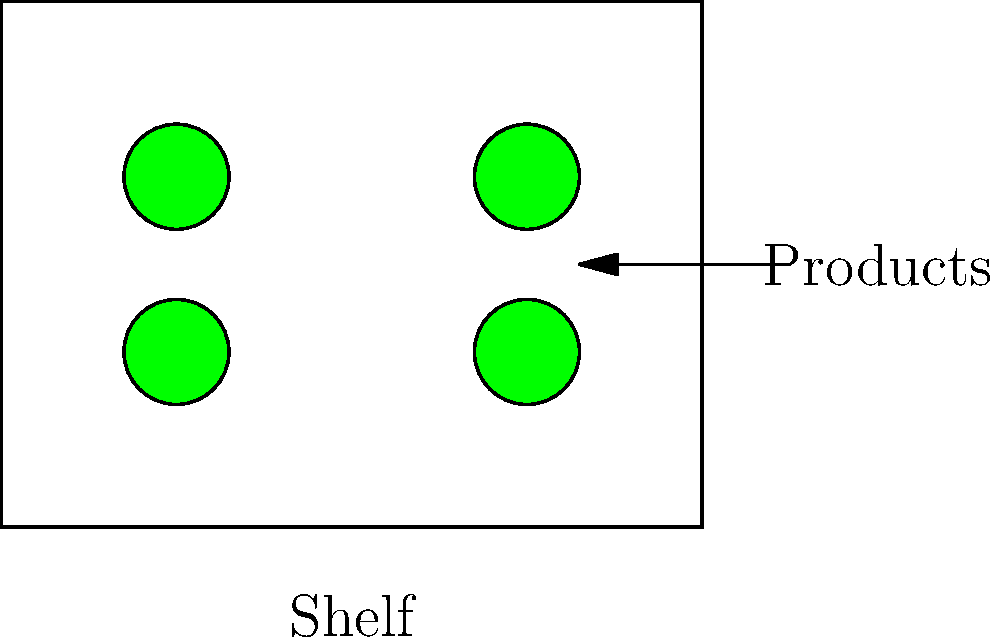A rectangular store shelf measures 4 units wide and 3 units high. Four circular sustainable products, each with a diameter of 0.6 units, are placed on the shelf as shown in the diagram. What is the maximum number of additional identical products that can be placed on the shelf without overlapping or extending beyond the shelf edges? To solve this problem, we need to follow these steps:

1. Calculate the area of each product:
   Area of one product = $\pi r^2 = \pi (0.3)^2 \approx 0.2827$ square units

2. Calculate the total area of the shelf:
   Area of shelf = $4 * 3 = 12$ square units

3. Calculate the area occupied by the existing products:
   Area occupied = $4 * 0.2827 \approx 1.1308$ square units

4. Calculate the remaining area:
   Remaining area = $12 - 1.1308 = 10.8692$ square units

5. Calculate the theoretical maximum number of additional products:
   Theoretical max = $10.8692 / 0.2827 \approx 38.45$

6. Round down to the nearest whole number:
   Maximum additional products = 38

However, this theoretical maximum doesn't account for the spacing between products and the edges of the shelf. In practice, we need to consider the grid-like arrangement of circular products.

7. Calculate the number of products that can fit along the width:
   Width capacity = $\lfloor 4 / 0.6 \rfloor = 6$ products

8. Calculate the number of products that can fit along the height:
   Height capacity = $\lfloor 3 / 0.6 \rfloor = 5$ products

9. Calculate the total capacity of the shelf:
   Total capacity = $6 * 5 = 30$ products

10. Subtract the existing products:
    Additional products = $30 - 4 = 26$

Therefore, the maximum number of additional identical products that can be placed on the shelf without overlapping or extending beyond the shelf edges is 26.
Answer: 26 products 